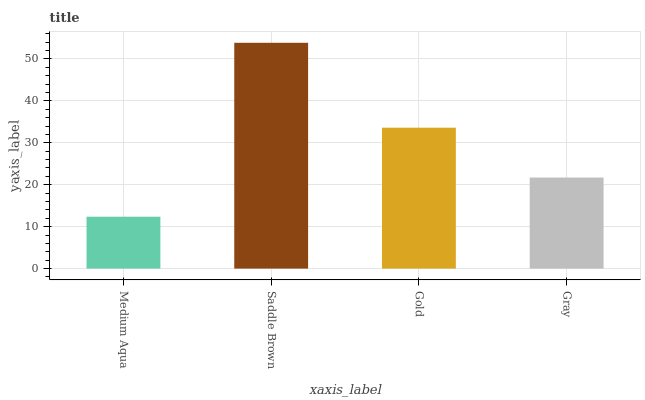Is Medium Aqua the minimum?
Answer yes or no. Yes. Is Saddle Brown the maximum?
Answer yes or no. Yes. Is Gold the minimum?
Answer yes or no. No. Is Gold the maximum?
Answer yes or no. No. Is Saddle Brown greater than Gold?
Answer yes or no. Yes. Is Gold less than Saddle Brown?
Answer yes or no. Yes. Is Gold greater than Saddle Brown?
Answer yes or no. No. Is Saddle Brown less than Gold?
Answer yes or no. No. Is Gold the high median?
Answer yes or no. Yes. Is Gray the low median?
Answer yes or no. Yes. Is Gray the high median?
Answer yes or no. No. Is Medium Aqua the low median?
Answer yes or no. No. 